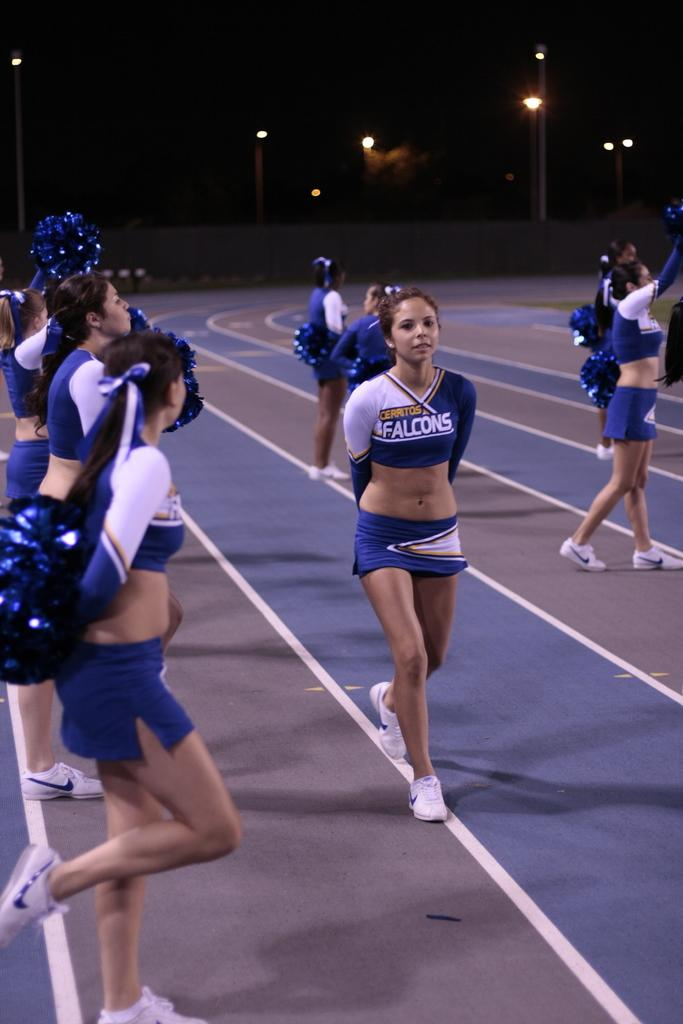<image>
Provide a brief description of the given image. The Falcons cheerleaders are dressed in blue and white. 